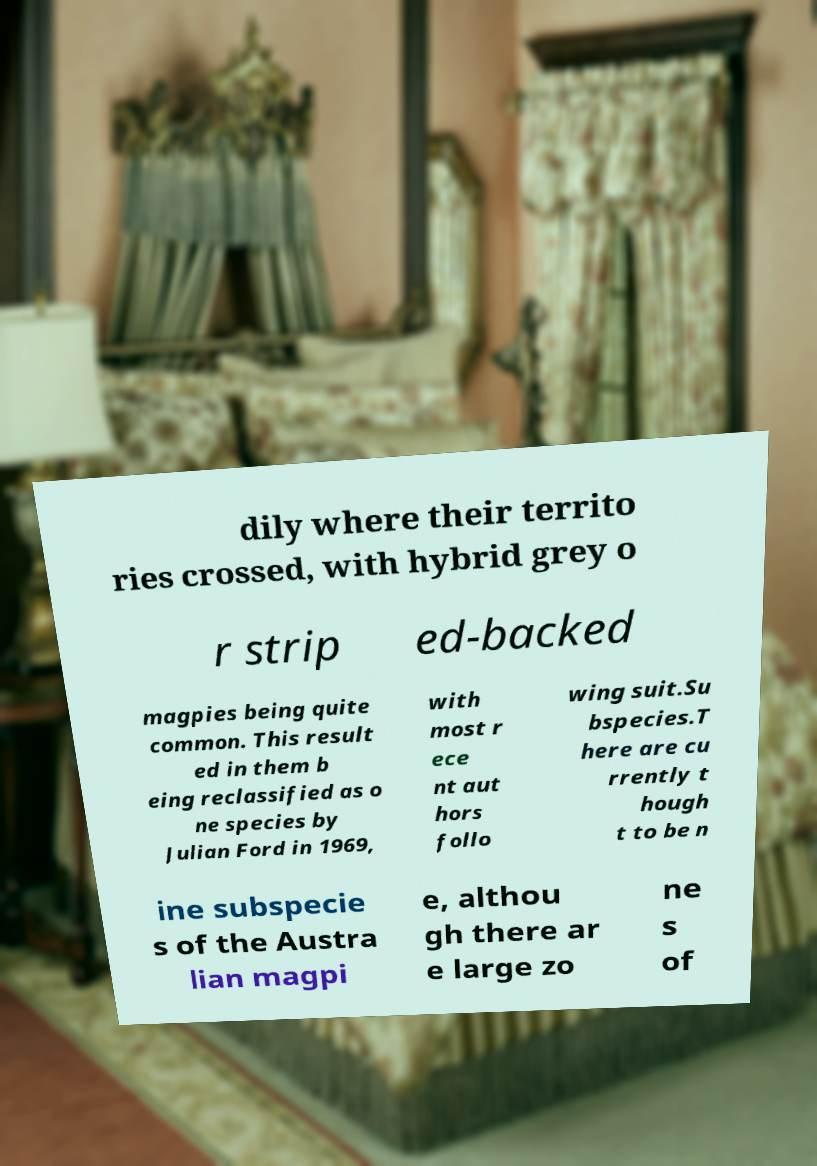Could you assist in decoding the text presented in this image and type it out clearly? dily where their territo ries crossed, with hybrid grey o r strip ed-backed magpies being quite common. This result ed in them b eing reclassified as o ne species by Julian Ford in 1969, with most r ece nt aut hors follo wing suit.Su bspecies.T here are cu rrently t hough t to be n ine subspecie s of the Austra lian magpi e, althou gh there ar e large zo ne s of 